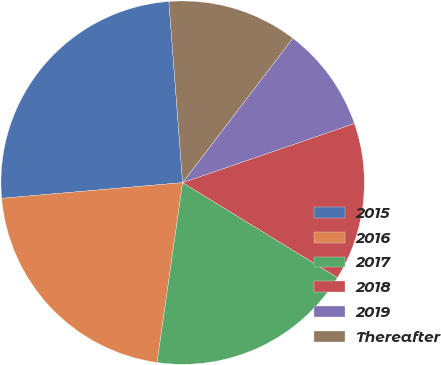Convert chart. <chart><loc_0><loc_0><loc_500><loc_500><pie_chart><fcel>2015<fcel>2016<fcel>2017<fcel>2018<fcel>2019<fcel>Thereafter<nl><fcel>25.17%<fcel>21.38%<fcel>18.49%<fcel>14.03%<fcel>9.35%<fcel>11.58%<nl></chart> 